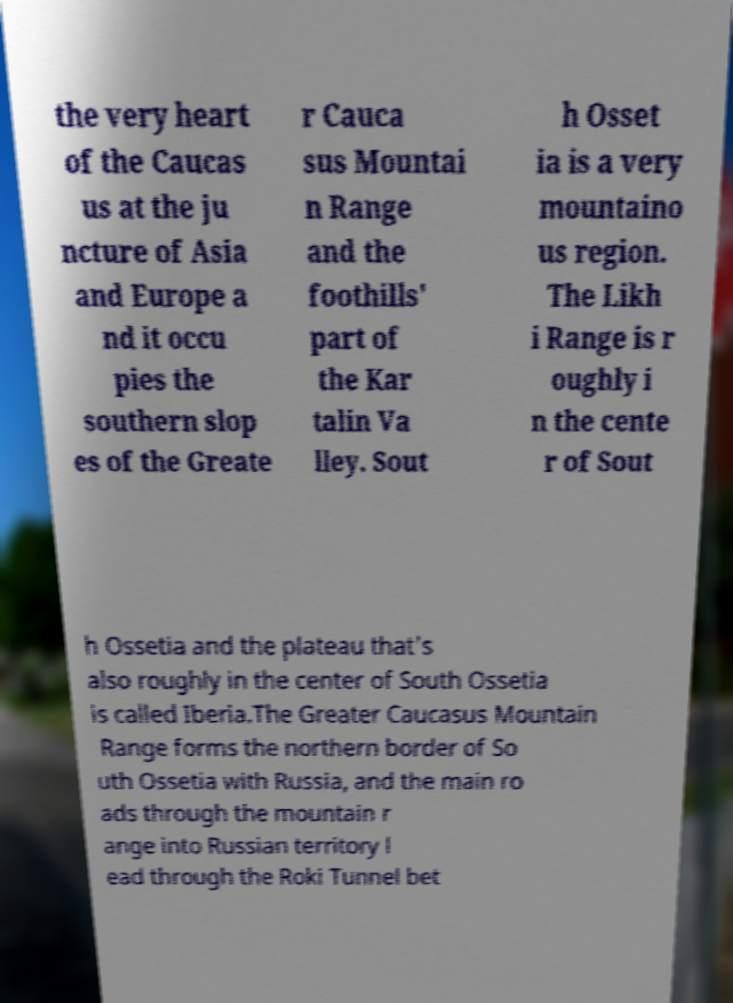Can you accurately transcribe the text from the provided image for me? the very heart of the Caucas us at the ju ncture of Asia and Europe a nd it occu pies the southern slop es of the Greate r Cauca sus Mountai n Range and the foothills' part of the Kar talin Va lley. Sout h Osset ia is a very mountaino us region. The Likh i Range is r oughly i n the cente r of Sout h Ossetia and the plateau that's also roughly in the center of South Ossetia is called Iberia.The Greater Caucasus Mountain Range forms the northern border of So uth Ossetia with Russia, and the main ro ads through the mountain r ange into Russian territory l ead through the Roki Tunnel bet 